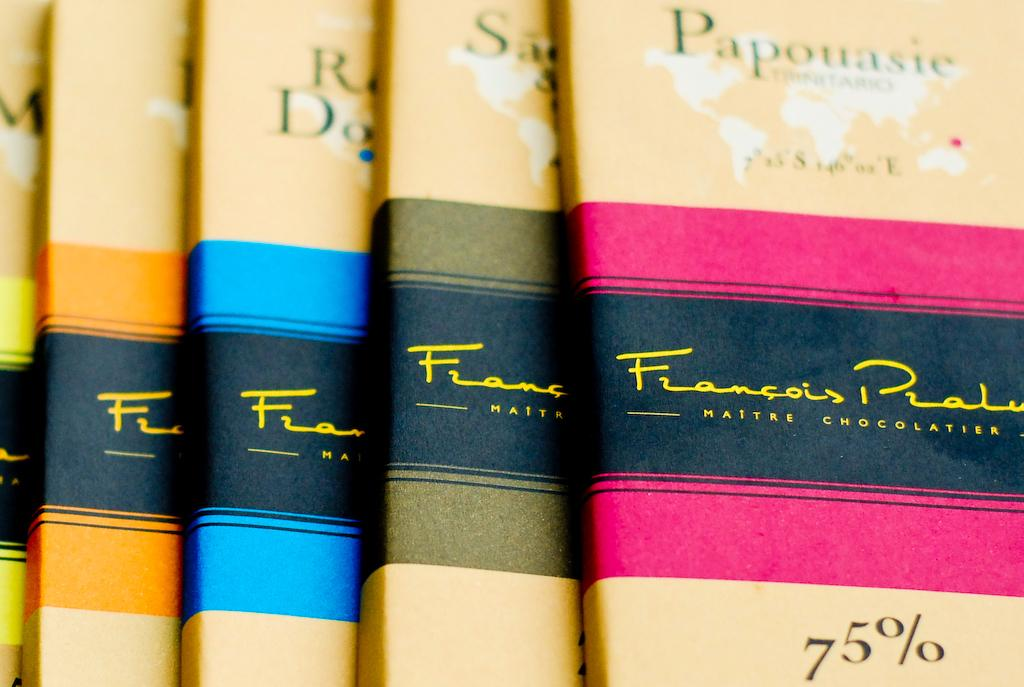<image>
Relay a brief, clear account of the picture shown. A book titled Papouasie is in a row of books. 